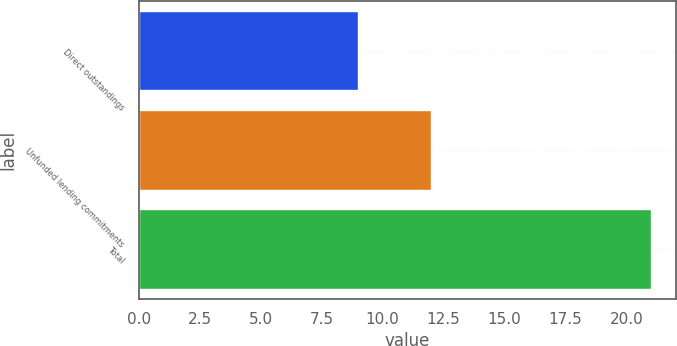Convert chart to OTSL. <chart><loc_0><loc_0><loc_500><loc_500><bar_chart><fcel>Direct outstandings<fcel>Unfunded lending commitments<fcel>Total<nl><fcel>9<fcel>12<fcel>21<nl></chart> 